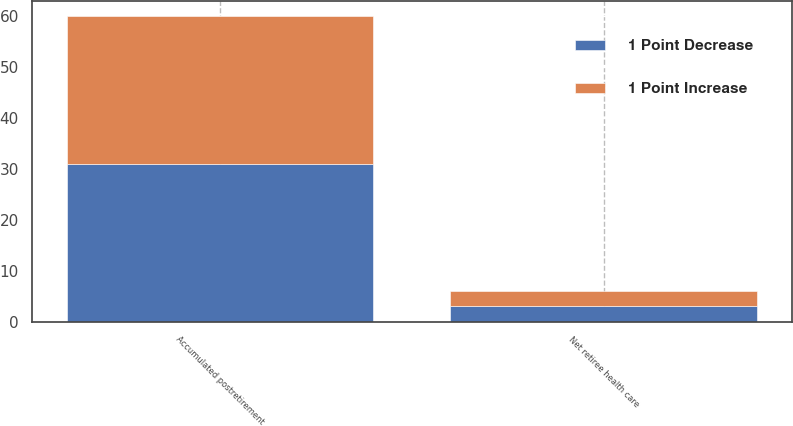Convert chart to OTSL. <chart><loc_0><loc_0><loc_500><loc_500><stacked_bar_chart><ecel><fcel>Accumulated postretirement<fcel>Net retiree health care<nl><fcel>1 Point Increase<fcel>29<fcel>3<nl><fcel>1 Point Decrease<fcel>31<fcel>3<nl></chart> 